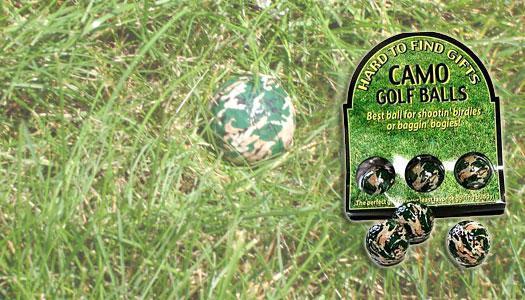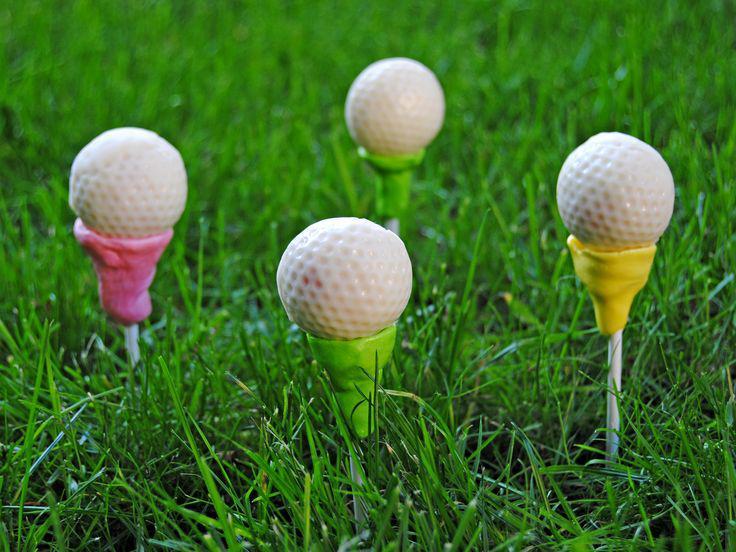The first image is the image on the left, the second image is the image on the right. For the images displayed, is the sentence "in 1 of the images, 1 white golf ball is sitting in grass." factually correct? Answer yes or no. No. The first image is the image on the left, the second image is the image on the right. Examine the images to the left and right. Is the description "Exactly four golf balls are arranged on grass in one image." accurate? Answer yes or no. Yes. 